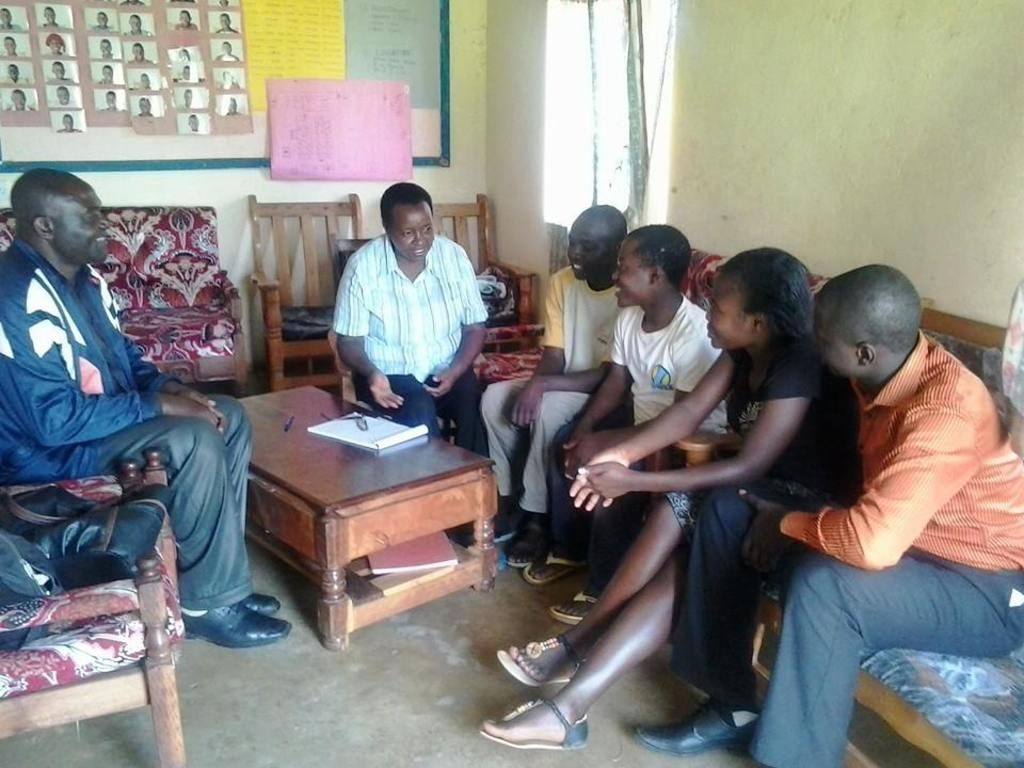What are the people in the image doing? There is a group of people sitting in the image. What is in front of the group of people? There is a table in front of the group. What is on the table? There is a book on the table. What type of furniture is present in the image? There are chairs in the image. What can be seen on the wall in the image? There are pictures on the wall. Where is the horse playing in the image? There is no horse or playground present in the image. 